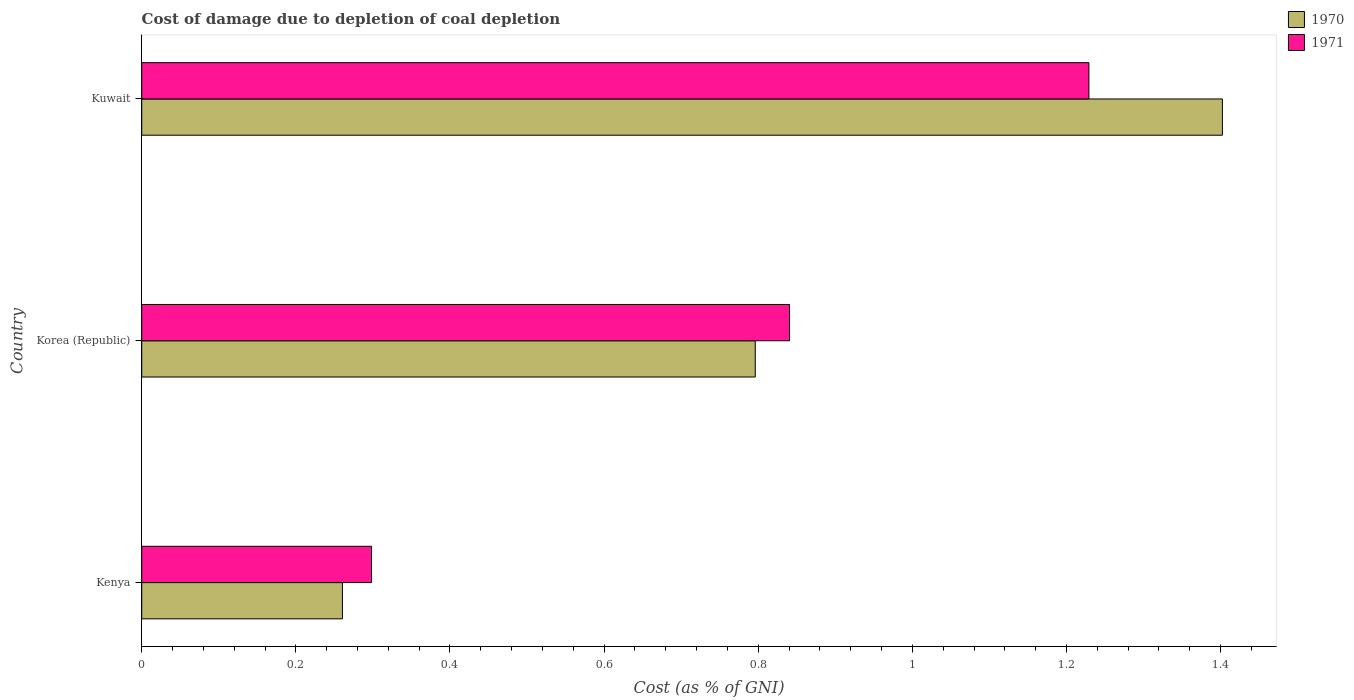Are the number of bars on each tick of the Y-axis equal?
Provide a short and direct response. Yes. How many bars are there on the 2nd tick from the bottom?
Make the answer very short. 2. What is the label of the 2nd group of bars from the top?
Provide a short and direct response. Korea (Republic). In how many cases, is the number of bars for a given country not equal to the number of legend labels?
Ensure brevity in your answer.  0. What is the cost of damage caused due to coal depletion in 1970 in Kuwait?
Provide a succinct answer. 1.4. Across all countries, what is the maximum cost of damage caused due to coal depletion in 1971?
Your response must be concise. 1.23. Across all countries, what is the minimum cost of damage caused due to coal depletion in 1971?
Provide a succinct answer. 0.3. In which country was the cost of damage caused due to coal depletion in 1971 maximum?
Ensure brevity in your answer.  Kuwait. In which country was the cost of damage caused due to coal depletion in 1971 minimum?
Give a very brief answer. Kenya. What is the total cost of damage caused due to coal depletion in 1971 in the graph?
Keep it short and to the point. 2.37. What is the difference between the cost of damage caused due to coal depletion in 1970 in Kenya and that in Kuwait?
Make the answer very short. -1.14. What is the difference between the cost of damage caused due to coal depletion in 1970 in Korea (Republic) and the cost of damage caused due to coal depletion in 1971 in Kenya?
Provide a short and direct response. 0.5. What is the average cost of damage caused due to coal depletion in 1970 per country?
Provide a succinct answer. 0.82. What is the difference between the cost of damage caused due to coal depletion in 1970 and cost of damage caused due to coal depletion in 1971 in Kenya?
Your response must be concise. -0.04. In how many countries, is the cost of damage caused due to coal depletion in 1971 greater than 0.8400000000000001 %?
Keep it short and to the point. 2. What is the ratio of the cost of damage caused due to coal depletion in 1970 in Kenya to that in Korea (Republic)?
Make the answer very short. 0.33. Is the cost of damage caused due to coal depletion in 1970 in Korea (Republic) less than that in Kuwait?
Keep it short and to the point. Yes. What is the difference between the highest and the second highest cost of damage caused due to coal depletion in 1971?
Your response must be concise. 0.39. What is the difference between the highest and the lowest cost of damage caused due to coal depletion in 1970?
Provide a succinct answer. 1.14. In how many countries, is the cost of damage caused due to coal depletion in 1971 greater than the average cost of damage caused due to coal depletion in 1971 taken over all countries?
Keep it short and to the point. 2. What does the 1st bar from the top in Korea (Republic) represents?
Offer a very short reply. 1971. How many bars are there?
Give a very brief answer. 6. How many countries are there in the graph?
Keep it short and to the point. 3. Does the graph contain any zero values?
Offer a terse response. No. Does the graph contain grids?
Provide a short and direct response. No. How many legend labels are there?
Offer a very short reply. 2. What is the title of the graph?
Your answer should be very brief. Cost of damage due to depletion of coal depletion. Does "2012" appear as one of the legend labels in the graph?
Make the answer very short. No. What is the label or title of the X-axis?
Provide a succinct answer. Cost (as % of GNI). What is the Cost (as % of GNI) in 1970 in Kenya?
Offer a terse response. 0.26. What is the Cost (as % of GNI) of 1971 in Kenya?
Give a very brief answer. 0.3. What is the Cost (as % of GNI) of 1970 in Korea (Republic)?
Offer a terse response. 0.8. What is the Cost (as % of GNI) of 1971 in Korea (Republic)?
Your answer should be compact. 0.84. What is the Cost (as % of GNI) of 1970 in Kuwait?
Ensure brevity in your answer.  1.4. What is the Cost (as % of GNI) of 1971 in Kuwait?
Provide a succinct answer. 1.23. Across all countries, what is the maximum Cost (as % of GNI) of 1970?
Give a very brief answer. 1.4. Across all countries, what is the maximum Cost (as % of GNI) in 1971?
Offer a very short reply. 1.23. Across all countries, what is the minimum Cost (as % of GNI) in 1970?
Your response must be concise. 0.26. Across all countries, what is the minimum Cost (as % of GNI) of 1971?
Your response must be concise. 0.3. What is the total Cost (as % of GNI) in 1970 in the graph?
Your response must be concise. 2.46. What is the total Cost (as % of GNI) of 1971 in the graph?
Your answer should be compact. 2.37. What is the difference between the Cost (as % of GNI) in 1970 in Kenya and that in Korea (Republic)?
Your response must be concise. -0.54. What is the difference between the Cost (as % of GNI) of 1971 in Kenya and that in Korea (Republic)?
Your response must be concise. -0.54. What is the difference between the Cost (as % of GNI) of 1970 in Kenya and that in Kuwait?
Your answer should be very brief. -1.14. What is the difference between the Cost (as % of GNI) in 1971 in Kenya and that in Kuwait?
Provide a succinct answer. -0.93. What is the difference between the Cost (as % of GNI) of 1970 in Korea (Republic) and that in Kuwait?
Offer a terse response. -0.61. What is the difference between the Cost (as % of GNI) of 1971 in Korea (Republic) and that in Kuwait?
Keep it short and to the point. -0.39. What is the difference between the Cost (as % of GNI) in 1970 in Kenya and the Cost (as % of GNI) in 1971 in Korea (Republic)?
Offer a terse response. -0.58. What is the difference between the Cost (as % of GNI) in 1970 in Kenya and the Cost (as % of GNI) in 1971 in Kuwait?
Offer a terse response. -0.97. What is the difference between the Cost (as % of GNI) of 1970 in Korea (Republic) and the Cost (as % of GNI) of 1971 in Kuwait?
Ensure brevity in your answer.  -0.43. What is the average Cost (as % of GNI) of 1970 per country?
Your response must be concise. 0.82. What is the average Cost (as % of GNI) of 1971 per country?
Your answer should be very brief. 0.79. What is the difference between the Cost (as % of GNI) in 1970 and Cost (as % of GNI) in 1971 in Kenya?
Ensure brevity in your answer.  -0.04. What is the difference between the Cost (as % of GNI) of 1970 and Cost (as % of GNI) of 1971 in Korea (Republic)?
Provide a short and direct response. -0.04. What is the difference between the Cost (as % of GNI) in 1970 and Cost (as % of GNI) in 1971 in Kuwait?
Ensure brevity in your answer.  0.17. What is the ratio of the Cost (as % of GNI) in 1970 in Kenya to that in Korea (Republic)?
Offer a very short reply. 0.33. What is the ratio of the Cost (as % of GNI) in 1971 in Kenya to that in Korea (Republic)?
Provide a succinct answer. 0.35. What is the ratio of the Cost (as % of GNI) in 1970 in Kenya to that in Kuwait?
Offer a very short reply. 0.19. What is the ratio of the Cost (as % of GNI) of 1971 in Kenya to that in Kuwait?
Offer a very short reply. 0.24. What is the ratio of the Cost (as % of GNI) in 1970 in Korea (Republic) to that in Kuwait?
Your answer should be compact. 0.57. What is the ratio of the Cost (as % of GNI) in 1971 in Korea (Republic) to that in Kuwait?
Give a very brief answer. 0.68. What is the difference between the highest and the second highest Cost (as % of GNI) of 1970?
Your answer should be compact. 0.61. What is the difference between the highest and the second highest Cost (as % of GNI) of 1971?
Provide a succinct answer. 0.39. What is the difference between the highest and the lowest Cost (as % of GNI) of 1970?
Provide a short and direct response. 1.14. What is the difference between the highest and the lowest Cost (as % of GNI) of 1971?
Your answer should be very brief. 0.93. 